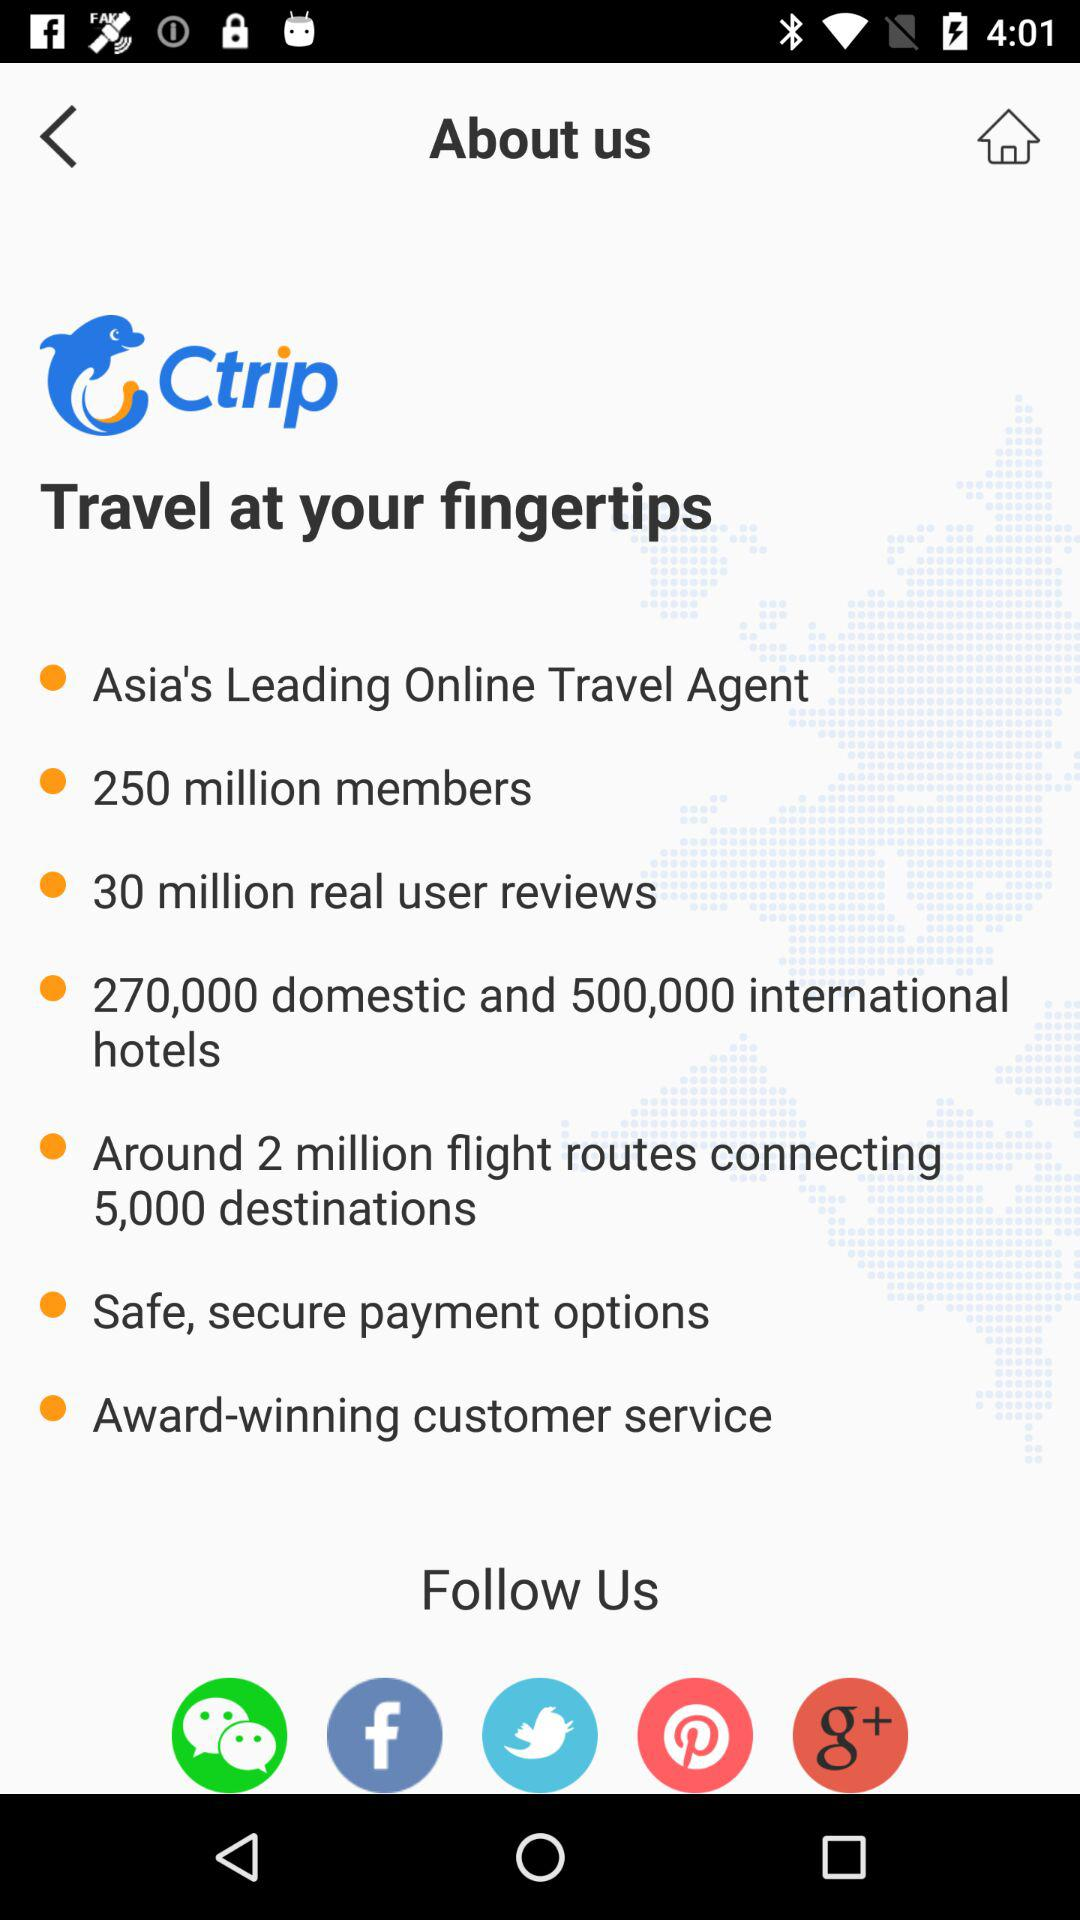How many members are there? There are 250 million members. 